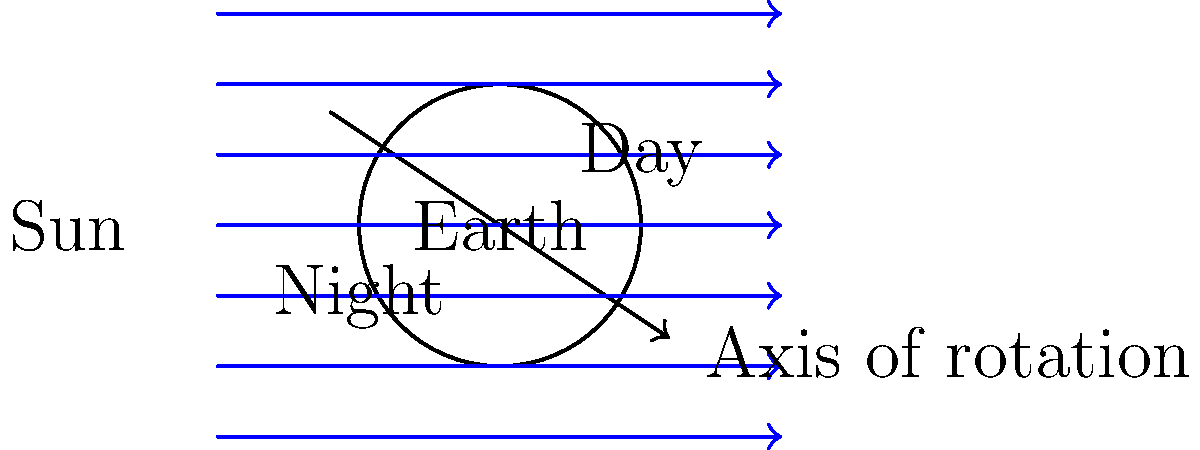As you're helping your 6th grader understand Earth's rotation, you show them this diagram. If the Earth rotates counterclockwise as viewed from above the North Pole, in which direction (left or right) would a point on the Earth's surface move relative to the sunlight? Let's break this down step-by-step:

1. The diagram shows the Earth, its axis of rotation, and light rays coming from the Sun on the left.

2. We're told that the Earth rotates counterclockwise when viewed from above the North Pole. In this diagram, that would be into the page.

3. To visualize this, imagine a point on the Earth's surface:
   - On the day side (right), it would be moving upwards.
   - On the night side (left), it would be moving downwards.

4. Relative to the sunlight, which is coming from the left:
   - A point on the Earth's surface would be moving from the night side to the day side.
   - This means it would be moving from left to right relative to the sunlight.

5. This movement explains why we experience sunrise in the east and sunset in the west:
   - As the Earth rotates, points on its surface move into sunlight (sunrise) from the left (west) side of the diagram.
   - They then move out of sunlight (sunset) on the right (east) side of the diagram.

Therefore, from the perspective given in the diagram, a point on the Earth's surface would move to the right relative to the sunlight.
Answer: Right 